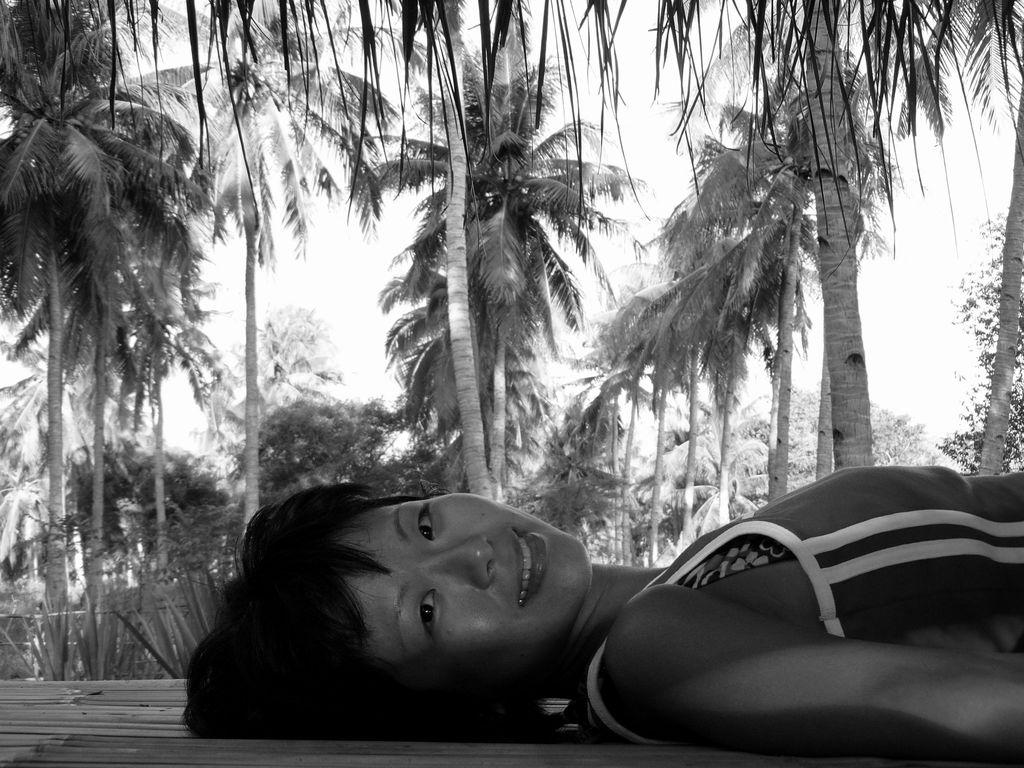What is the person in the image doing? The person is lying on a surface in the image. What can be seen in the background behind the person? There is a group of trees visible behind the person. What is visible at the top of the image? The sky is visible at the top of the image. What type of guitar is the person playing in the image? There is no guitar present in the image; the person is simply lying on a surface. 